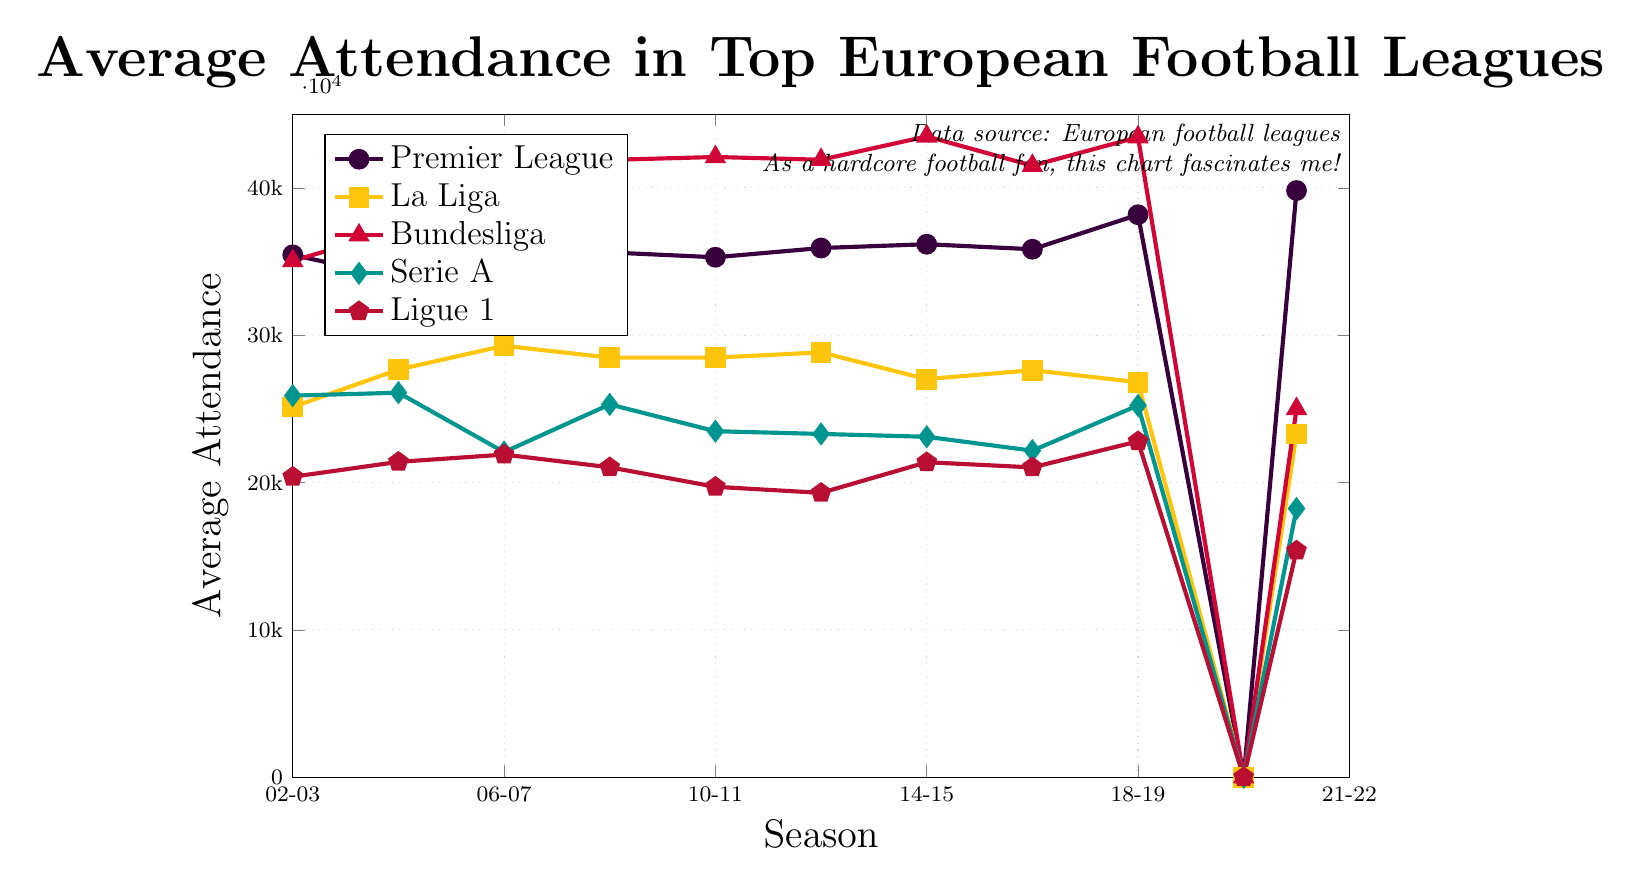What's the average attendance for Bundesliga in the 2006-07 season? Locate the data point for Bundesliga in the 2006-07 season, which is represented by a triangle marker colored red. The value is 39,774.
Answer: 39,774 In which season did the Premier League experience the highest average attendance? Look at the line representing the Premier League (purple with circle markers). The peak value on the y-axis is just before 2022, which corresponds to the 2021-22 season.
Answer: 2021-22 How does Serie A's average attendance in 2012-13 compare to La Liga's in the same season? Locate the data points for both leagues in the 2012-13 season. Serie A's attendance is about 23,300, and La Liga's is around 28,837.
Answer: La Liga had higher attendance By how much did Ligue 1’s average attendance decrease from the 2002-03 season to the 2021-22 season? Find the values for Ligue 1 in 2002-03 and 2021-22. In 2002-03, it was 20,392, and in 2021-22, it was 15,380. Calculate the difference: 20,392 - 15,380 = 5,012.
Answer: 5,012 Which league had the highest average attendance in the 2008-09 season and what was the value? Check the y-values for all leagues in the 2008-09 season. Bundesliga has the highest attendance, approximately 41,904.
Answer: Bundesliga, 41,904 What is the trend in average attendance for La Liga from 2006-07 to 2014-15? Observe the line representing La Liga (yellow with square markers) from 2006-07 to 2014-15. The attendance increased initially (2006-07: 29,287) and then decreased to 27,021 by 2014-15.
Answer: Initial increase, followed by a decrease Determine the overall change in average attendance for the Premier League over the two decades covered. Identify the first and last data points for the Premier League (2002-03 and 2021-22 seasons). The attendance increased from 35,459 to 39,824. Calculate the change: 39,824 - 35,459 = 4,365.
Answer: Increase by 4,365 Which seasons saw no attendance recorded for any of the leagues? Locate the data points with zero values for all leagues. The season corresponding to these points is 2020-21.
Answer: 2020-21 Among the five leagues, which one had the lowest average attendance in the 2016-17 season? Find the values for all leagues in the 2016-17 season. Ligue 1 (red with pentagon markers) has the lowest attendance, around 21,029.
Answer: Ligue 1 